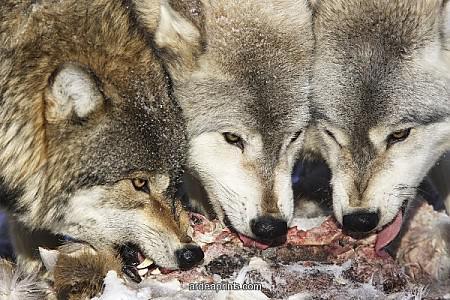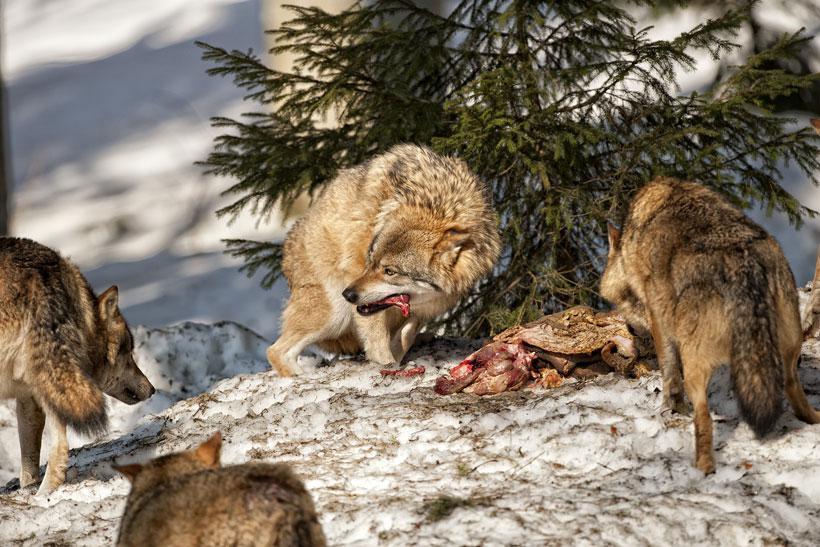The first image is the image on the left, the second image is the image on the right. For the images displayed, is the sentence "All of the wolves are out in the snow." factually correct? Answer yes or no. Yes. 